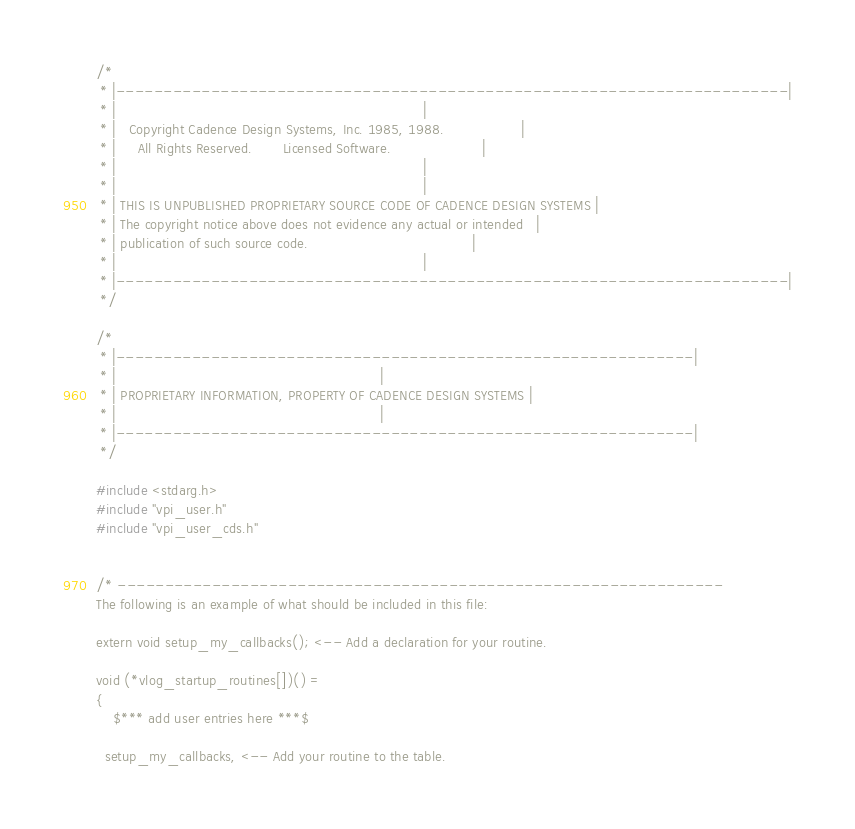Convert code to text. <code><loc_0><loc_0><loc_500><loc_500><_C_>/*
 * |-----------------------------------------------------------------------|
 * |                                                                       |
 * |   Copyright Cadence Design Systems, Inc. 1985, 1988.                  |
 * |     All Rights Reserved.       Licensed Software.                     |
 * |                                                                       |
 * |                                                                       |
 * | THIS IS UNPUBLISHED PROPRIETARY SOURCE CODE OF CADENCE DESIGN SYSTEMS |
 * | The copyright notice above does not evidence any actual or intended   |
 * | publication of such source code.                                      |
 * |                                                                       |
 * |-----------------------------------------------------------------------|
 */

/*
 * |-------------------------------------------------------------|
 * |                                                             |
 * | PROPRIETARY INFORMATION, PROPERTY OF CADENCE DESIGN SYSTEMS |
 * |                                                             |
 * |-------------------------------------------------------------|
 */

#include <stdarg.h>
#include "vpi_user.h"
#include "vpi_user_cds.h"


/* ----------------------------------------------------------------
The following is an example of what should be included in this file:

extern void setup_my_callbacks(); <-- Add a declaration for your routine.

void (*vlog_startup_routines[])() = 
{
    $*** add user entries here ***$

  setup_my_callbacks, <-- Add your routine to the table. 
</code> 